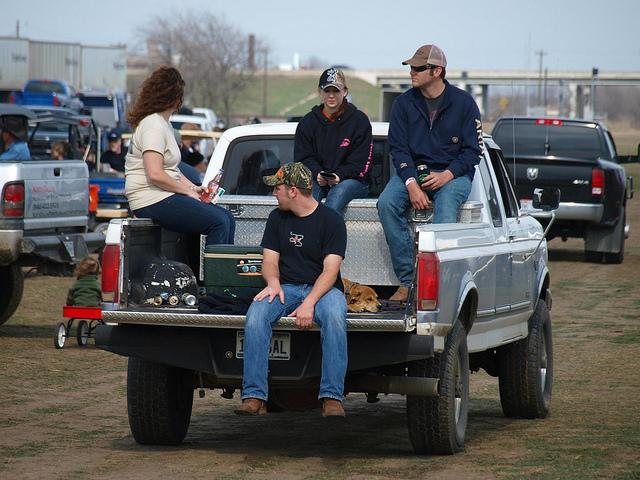What is the name for this sort of event? tailgate 